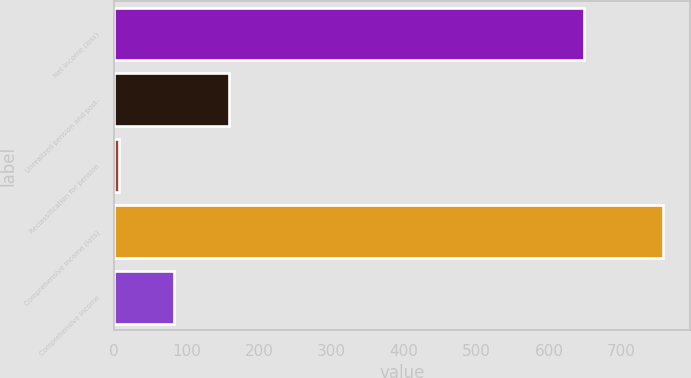<chart> <loc_0><loc_0><loc_500><loc_500><bar_chart><fcel>Net income (loss)<fcel>Unrealized pension and post-<fcel>Reclassification for pension<fcel>Comprehensive income (loss)<fcel>Comprehensive income<nl><fcel>648<fcel>158.96<fcel>6.4<fcel>757.3<fcel>82.68<nl></chart> 